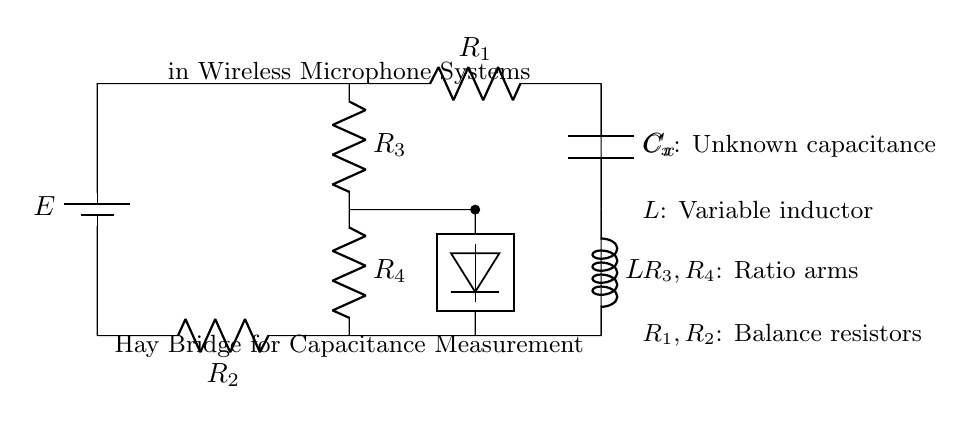What component is used to measure the unknown capacitance? The component used to measure the unknown capacitance is labeled as C_x in the circuit.
Answer: C_x What type of circuit is this? This circuit is known as a Hay Bridge circuit, which is specifically designed for measuring capacitance.
Answer: Hay Bridge How many resistors are there in total? There are four resistors in total, labeled as R_1, R_2, R_3, and R_4.
Answer: Four What is the value of the variable component in the circuit? The variable component in the circuit is labeled as L, which refers to a variable inductor.
Answer: L What does the detector do in this circuit? The detector measures the balance or unbalance of the bridge, indicating the capacitance value based on the circuit's configuration.
Answer: Measure balance What are the arms of the bridge circuit referred to? The arms of the bridge circuit are referred to as the ratio arms, specifically R_3 and R_4.
Answer: Ratio arms What is the role of the battery in this circuit? The battery, labeled as E, provides the necessary voltage to power the circuit, enabling the measurement process.
Answer: Provide voltage 